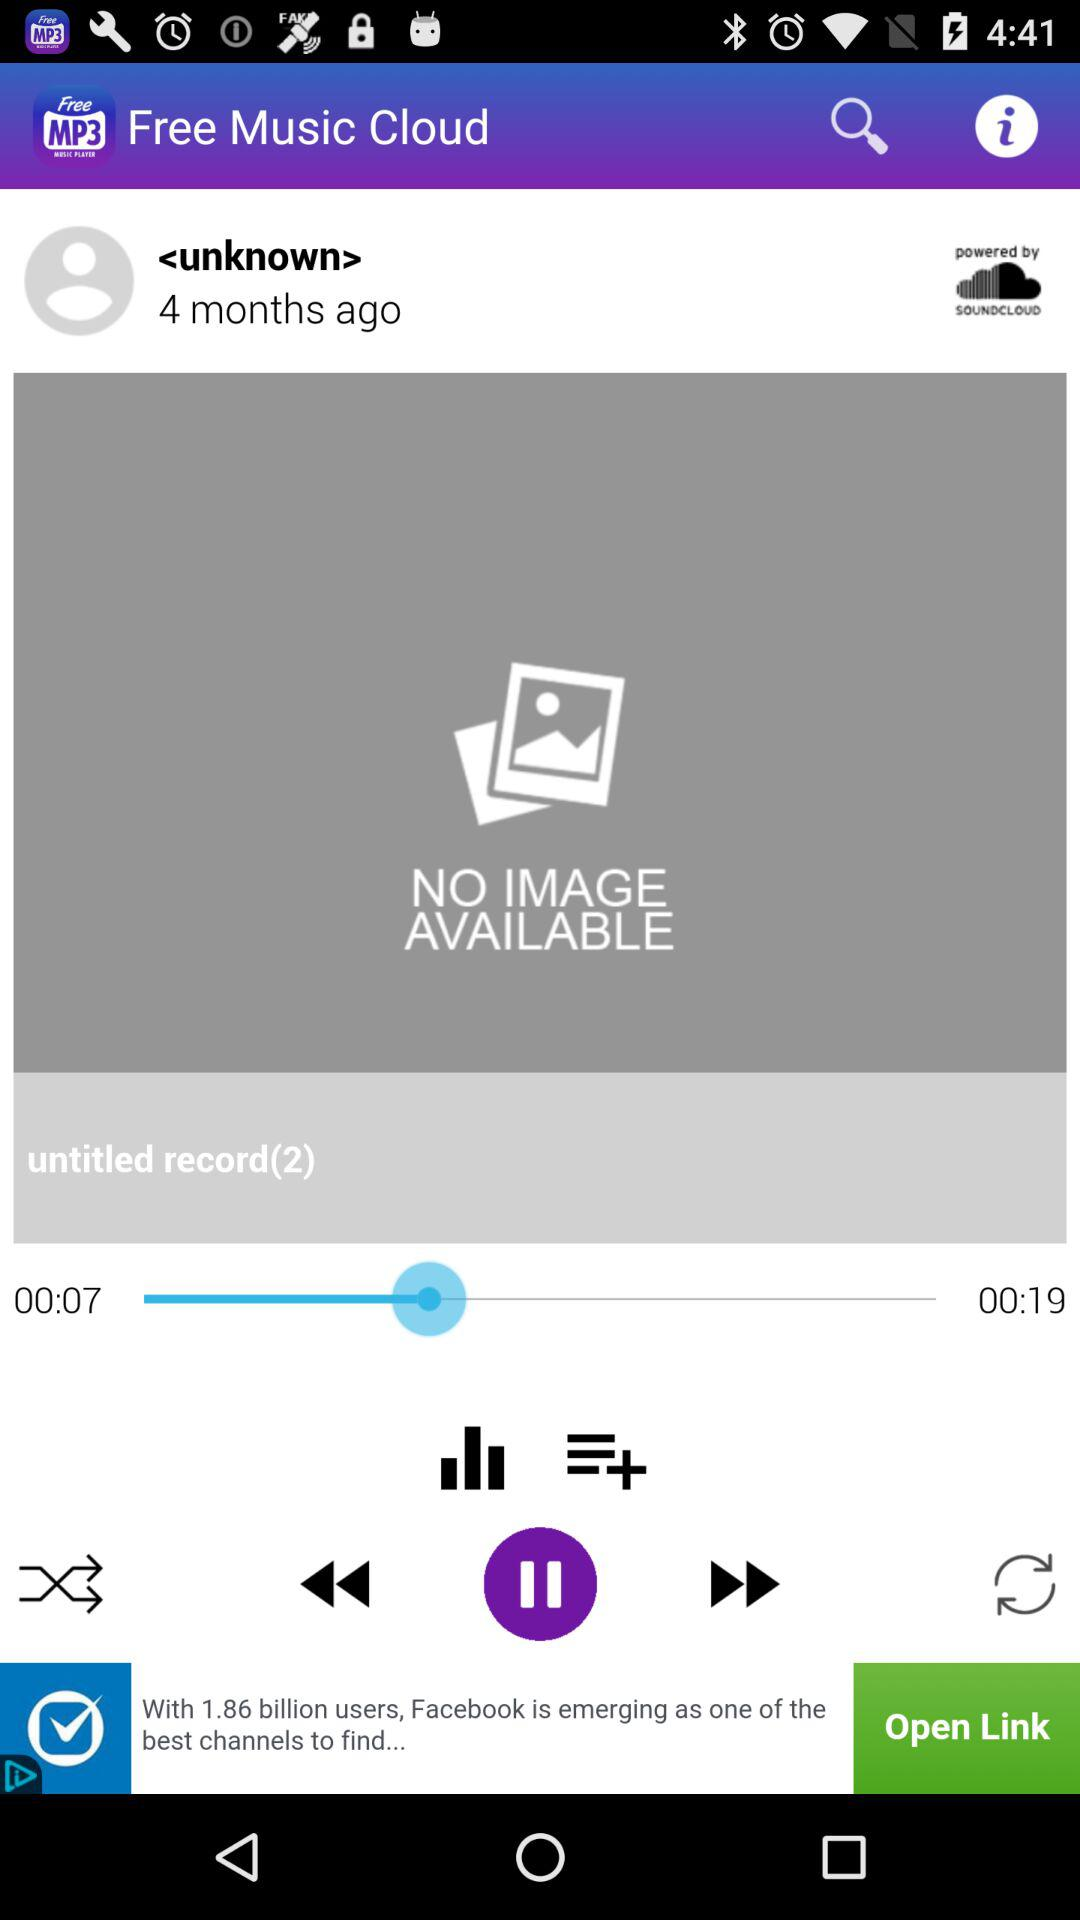How many seconds longer is the second track than the first track? 12 